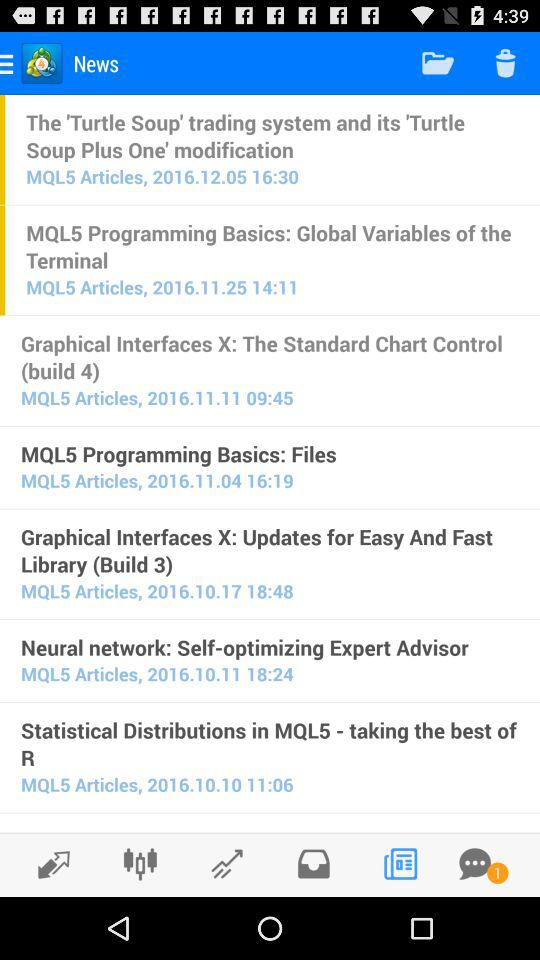When was the "MQL5 Programming Basics: Global Variables of the Terminal" article published? The "MQL5 Programming Basics: Global Variables of the Terminal" article was published on November 25, 2016 at 14:11. 